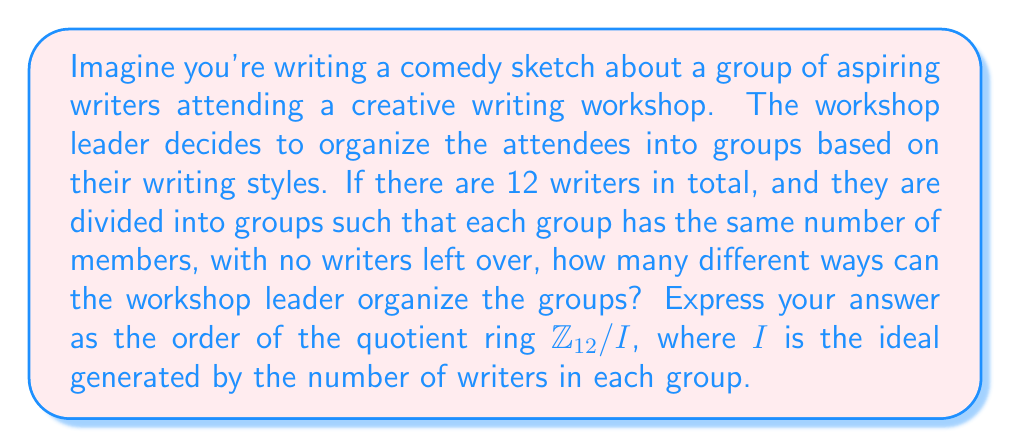Could you help me with this problem? To solve this problem, we need to follow these steps:

1) First, let's determine the possible group sizes. The factors of 12 are 1, 2, 3, 4, 6, and 12. These represent the possible numbers of writers in each group.

2) Now, we need to construct the quotient ring $\mathbb{Z}_{12} / I$ for each of these cases. The ideal $I$ will be generated by the number of writers in each group.

3) For each case, we'll determine the order of the quotient ring:

   a) If $I = \langle 1 \rangle$, then $\mathbb{Z}_{12} / I \cong \{0\}$, order 1
   b) If $I = \langle 2 \rangle$, then $\mathbb{Z}_{12} / I \cong \mathbb{Z}_2$, order 2
   c) If $I = \langle 3 \rangle$, then $\mathbb{Z}_{12} / I \cong \mathbb{Z}_3$, order 3
   d) If $I = \langle 4 \rangle$, then $\mathbb{Z}_{12} / I \cong \mathbb{Z}_4$, order 4
   e) If $I = \langle 6 \rangle$, then $\mathbb{Z}_{12} / I \cong \mathbb{Z}_6$, order 6
   f) If $I = \langle 12 \rangle$, then $\mathbb{Z}_{12} / I \cong \{0\}$, order 1

4) The order of each quotient ring represents the number of distinct elements in the ring, which corresponds to the number of ways the workshop leader can organize the groups for each group size.

5) To find the total number of ways to organize the groups, we sum the orders of all these quotient rings:

   $1 + 2 + 3 + 4 + 6 + 1 = 17$

Therefore, there are 17 different ways the workshop leader can organize the groups.
Answer: The workshop leader can organize the groups in 17 different ways, which is equal to the sum of the orders of the quotient rings $\mathbb{Z}_{12} / I$ for all possible ideals $I$ generated by the factors of 12. 